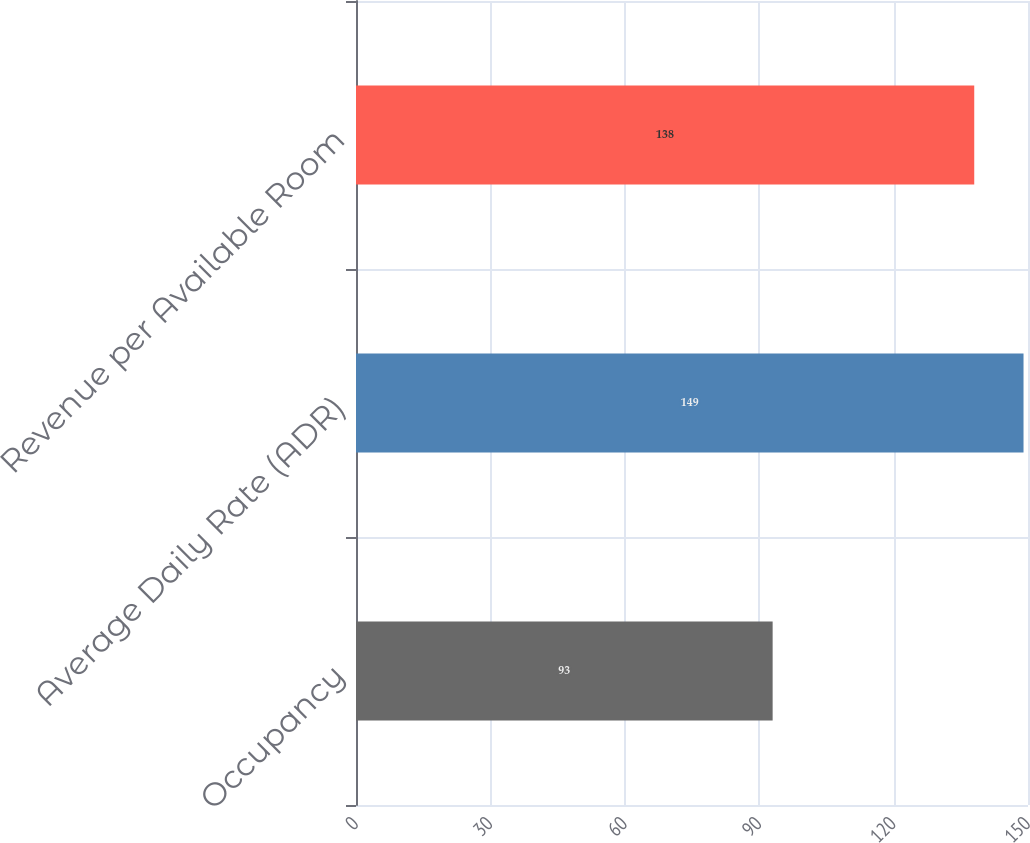<chart> <loc_0><loc_0><loc_500><loc_500><bar_chart><fcel>Occupancy<fcel>Average Daily Rate (ADR)<fcel>Revenue per Available Room<nl><fcel>93<fcel>149<fcel>138<nl></chart> 